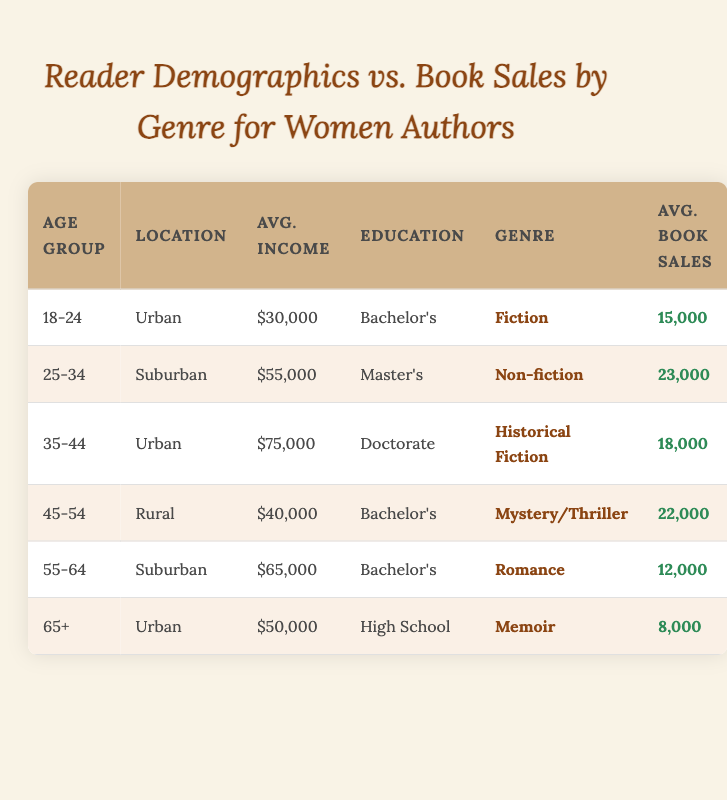What genre has the highest average book sales? By looking at the "Avg. Book Sales" column, the highest value is 23,000 associated with the "Non-fiction" genre which corresponds to the 25-34 age group.
Answer: Non-fiction Which age group has the lowest average book sales? The "Avg. Book Sales" column shows that the age group "65+" has the lowest sales at 8,000.
Answer: 65+ What is the total average book sales for the genres represented in ages 18-24 and 45-54? For age group 18-24, the average book sales are 15,000 (Fiction) and for 45-54, it is 22,000 (Mystery/Thriller). Adding these gives 15,000 + 22,000 = 37,000.
Answer: 37,000 Is there a correlation between education level and average book sales for women authors? By analyzing the data, we see that higher education levels do not necessarily correlate with higher sales. For instance, "Doctorate" has 18,000 while "Bachelor's" appears with varying sales. It’s inconclusive based on visible data.
Answer: No Which location has the second highest average income among the groups? The second highest value in the "Avg. Income" column is 65,000 from the Suburban location represented by the age group 55-64.
Answer: Suburban What is the average book sales among all age groups with Bachelor's degrees? The age groups with Bachelor's degrees are 18-24 (15,000), 45-54 (22,000), and 55-64 (12,000). To find the average, we sum these sales: 15,000 + 22,000 + 12,000 = 49,000, and divide by 3, giving us 49,000 / 3 = approximately 16,333.
Answer: 16,333 Which genre has the highest average income in the displayed demographics? The "Historical Fiction" genre, associated with the 35-44 age group, has the highest average income of 75,000.
Answer: Historical Fiction What percentage of the total average book sales does the genre Romance represent? The total average book sales from the table is 15,000 (Fiction) + 23,000 (Non-fiction) + 18,000 (Historical Fiction) + 22,000 (Mystery/Thriller) + 12,000 (Romance) + 8,000 (Memoir) = 98,000. The percentage for Romance is (12,000 / 98,000) * 100 ≈ 12.24%.
Answer: 12.24% What is the relationship between age group and average book sales? A comparative analysis shows that younger age groups such as 18-24 tend to have lower sales compared to the 25-34 and 45-54 age groups, suggesting that sales may increase with certain age groups but decrease at higher ages.
Answer: Mixed relationship 